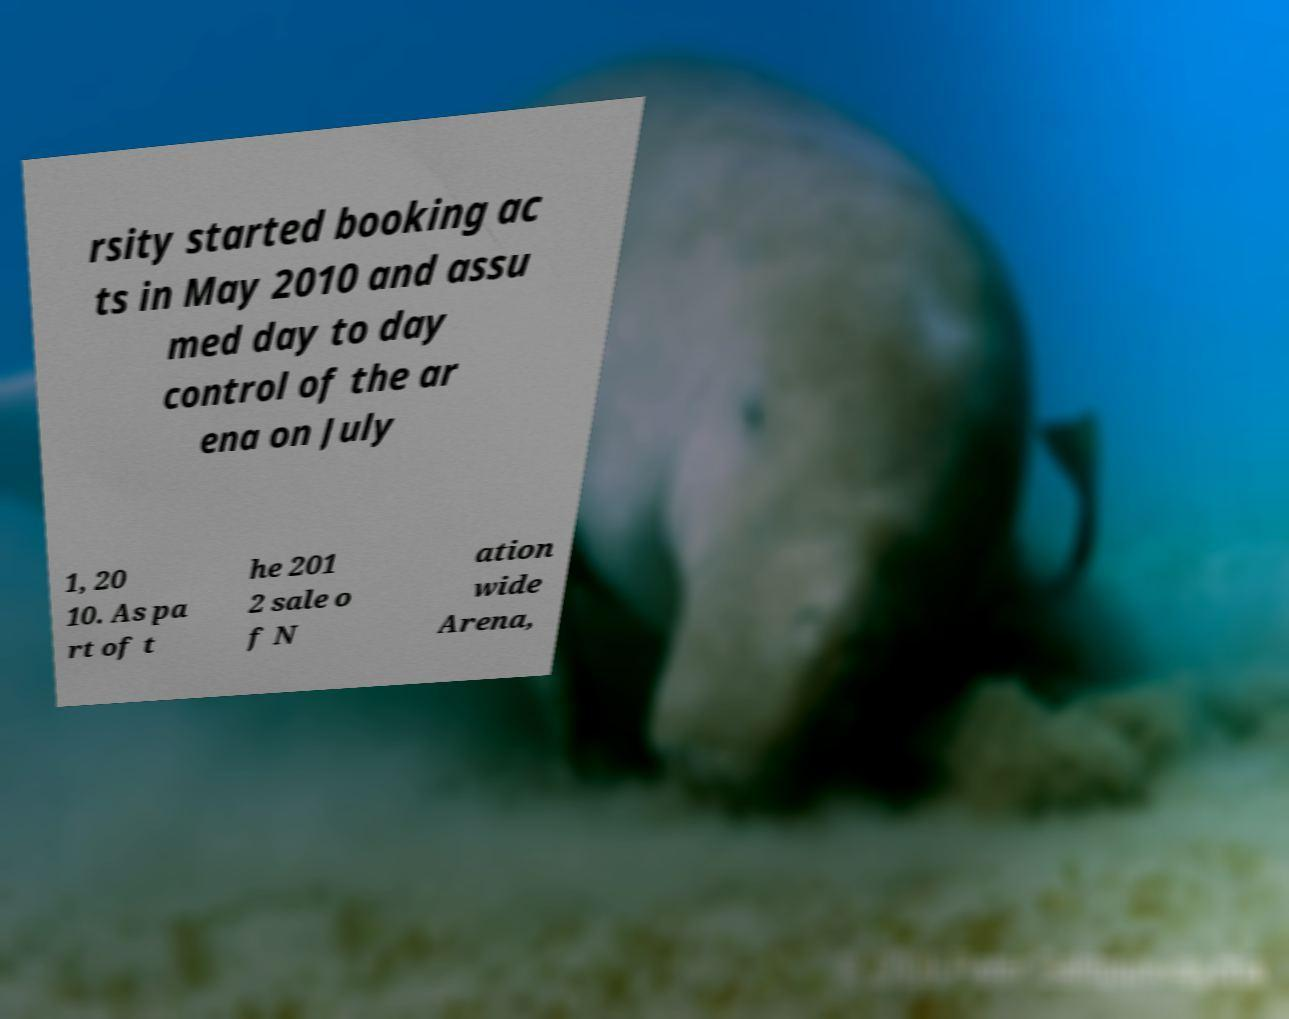Can you read and provide the text displayed in the image?This photo seems to have some interesting text. Can you extract and type it out for me? rsity started booking ac ts in May 2010 and assu med day to day control of the ar ena on July 1, 20 10. As pa rt of t he 201 2 sale o f N ation wide Arena, 